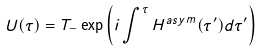Convert formula to latex. <formula><loc_0><loc_0><loc_500><loc_500>U ( \tau ) = T _ { - } \exp \left ( i \int ^ { \tau } H ^ { a s y m } ( \tau ^ { \prime } ) d \tau ^ { \prime } \right )</formula> 